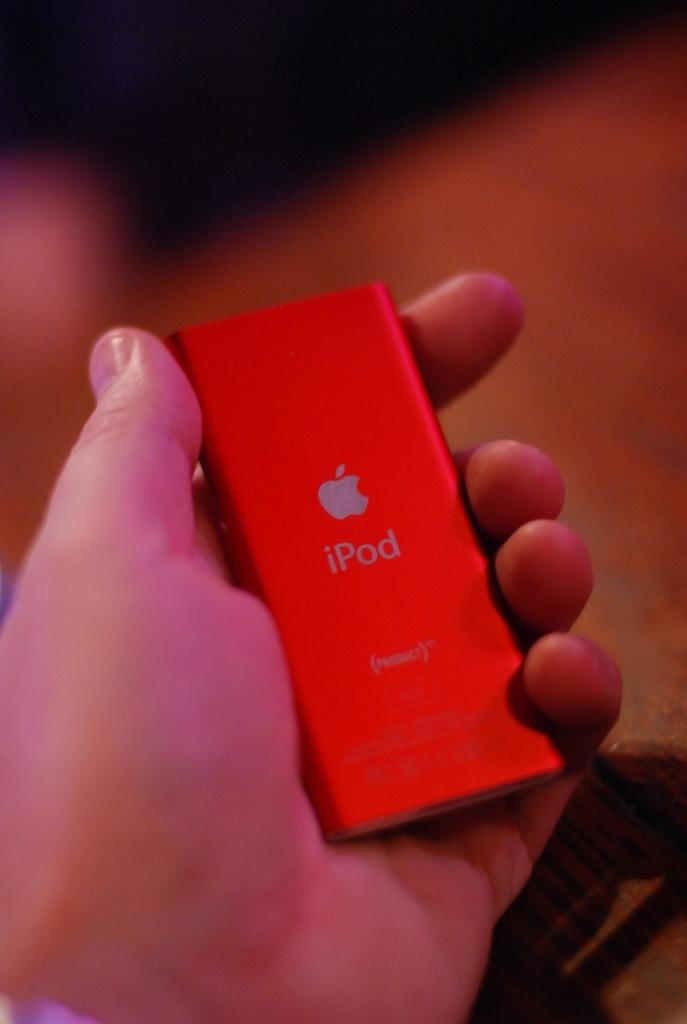<image>
Describe the image concisely. man holding a red ipod in his hands 